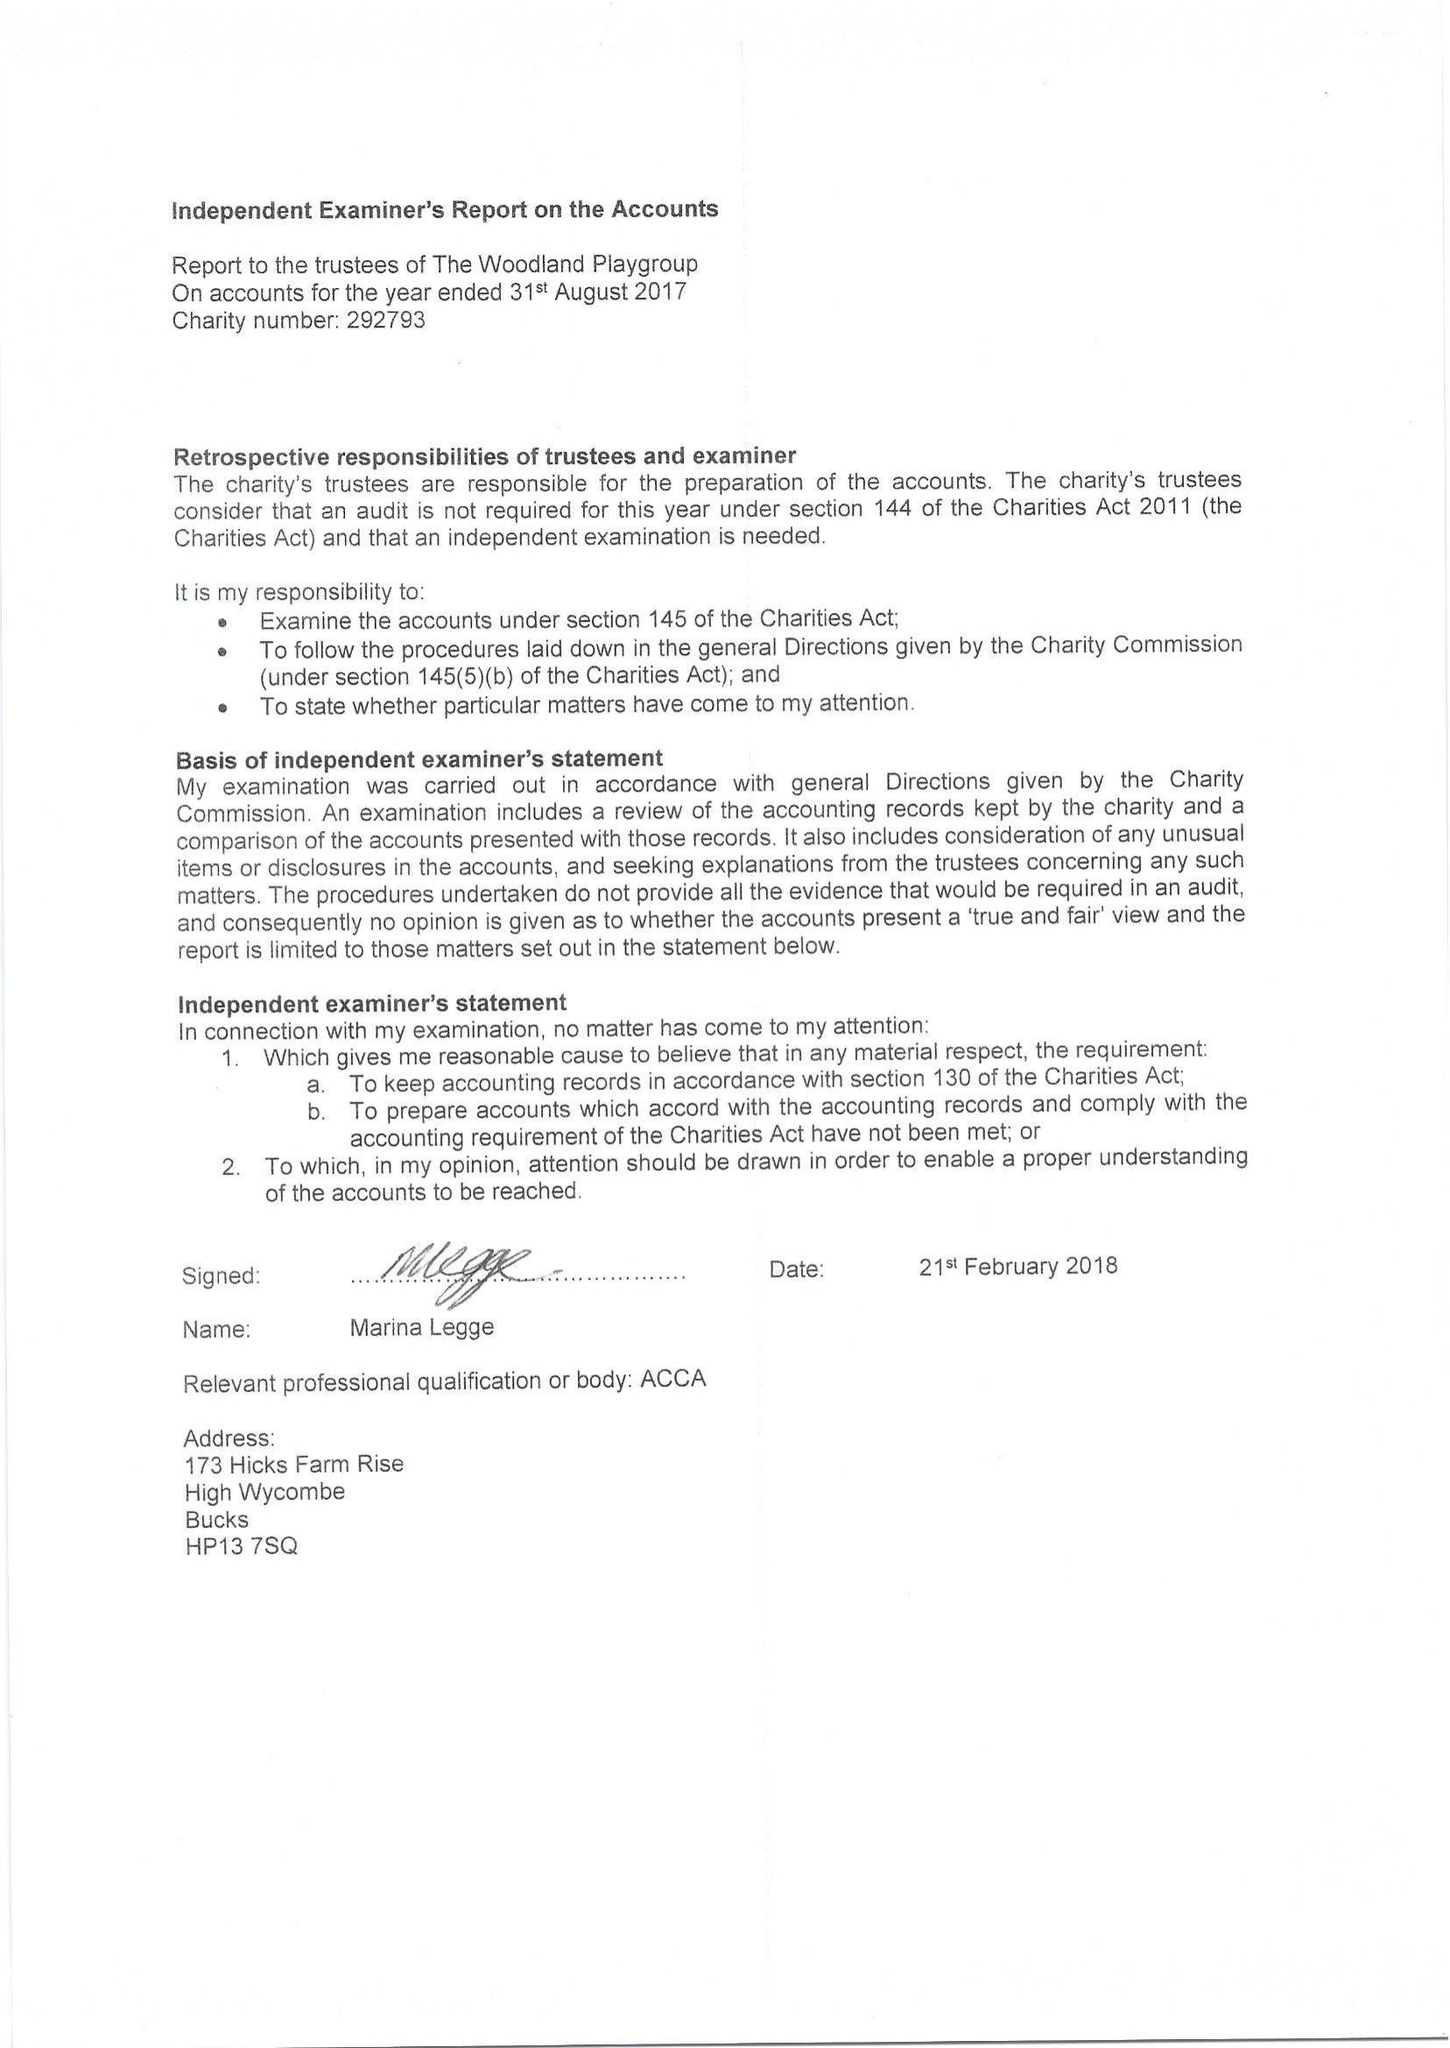What is the value for the spending_annually_in_british_pounds?
Answer the question using a single word or phrase. 97865.09 